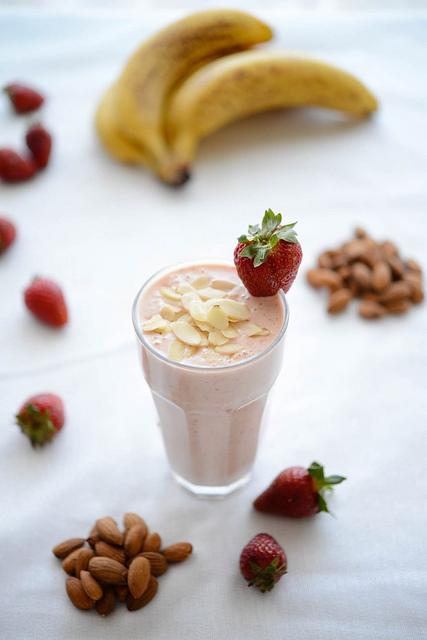How many strawberries are on the table?
Concise answer only. 8. What color is the table top?
Give a very brief answer. White. What fruits are on the table?
Short answer required. Banana strawberry. 